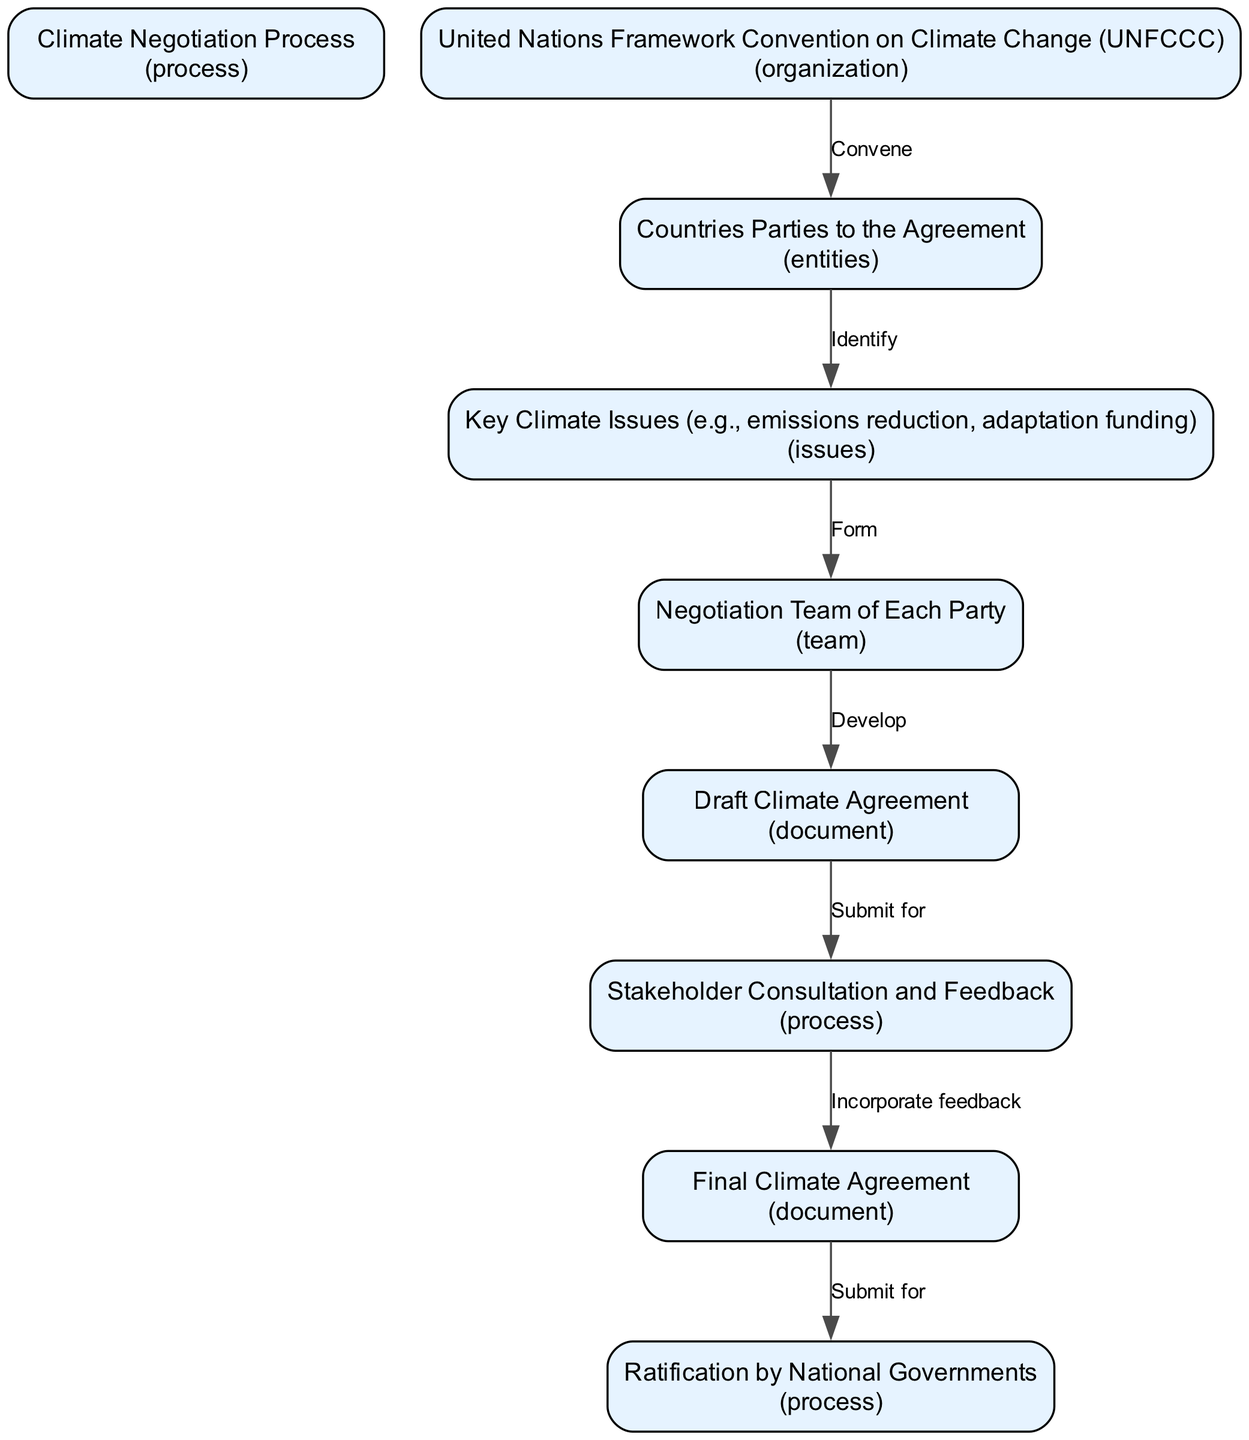What is the first step in the climate negotiation process? The first step is the United Nations Framework Convention on Climate Change (UNFCCC) convening the Parties.
Answer: Convene How many main documents are produced in the negotiation process? The diagram shows two main documents: the Draft Climate Agreement and the Final Climate Agreement.
Answer: Two What initiates the formation of the negotiation team? The formation of the negotiation team is initiated by identifying Key Climate Issues.
Answer: Identify What comes after the Draft Climate Agreement is created? After the Draft Climate Agreement is developed, it is submitted for Stakeholder Consultation and Feedback.
Answer: Submit for Which process occurs after incorporating feedback? After incorporating feedback, the next process is the ratification by national governments.
Answer: Ratification What entity is responsible for convening the countries involved in the agreement? The entity responsible for convening is the United Nations Framework Convention on Climate Change (UNFCCC).
Answer: UNFCCC What do the Parties identify in the negotiation process? The Parties identify Key Climate Issues such as emissions reduction and adaptation funding.
Answer: Key Climate Issues How do stakeholder consultations influence the negotiation process? Stakeholder consultations lead to the incorporation of feedback into the Final Climate Agreement.
Answer: Incorporate feedback What type of agreement is finalized at the end of the negotiation process? The type of agreement finalized at the end of the process is the Final Climate Agreement.
Answer: Final Climate Agreement 